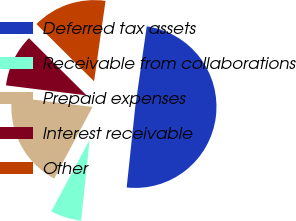Convert chart to OTSL. <chart><loc_0><loc_0><loc_500><loc_500><pie_chart><fcel>Deferred tax assets<fcel>Receivable from collaborations<fcel>Prepaid expenses<fcel>Interest receivable<fcel>Other<nl><fcel>49.43%<fcel>6.15%<fcel>19.13%<fcel>10.48%<fcel>14.81%<nl></chart> 